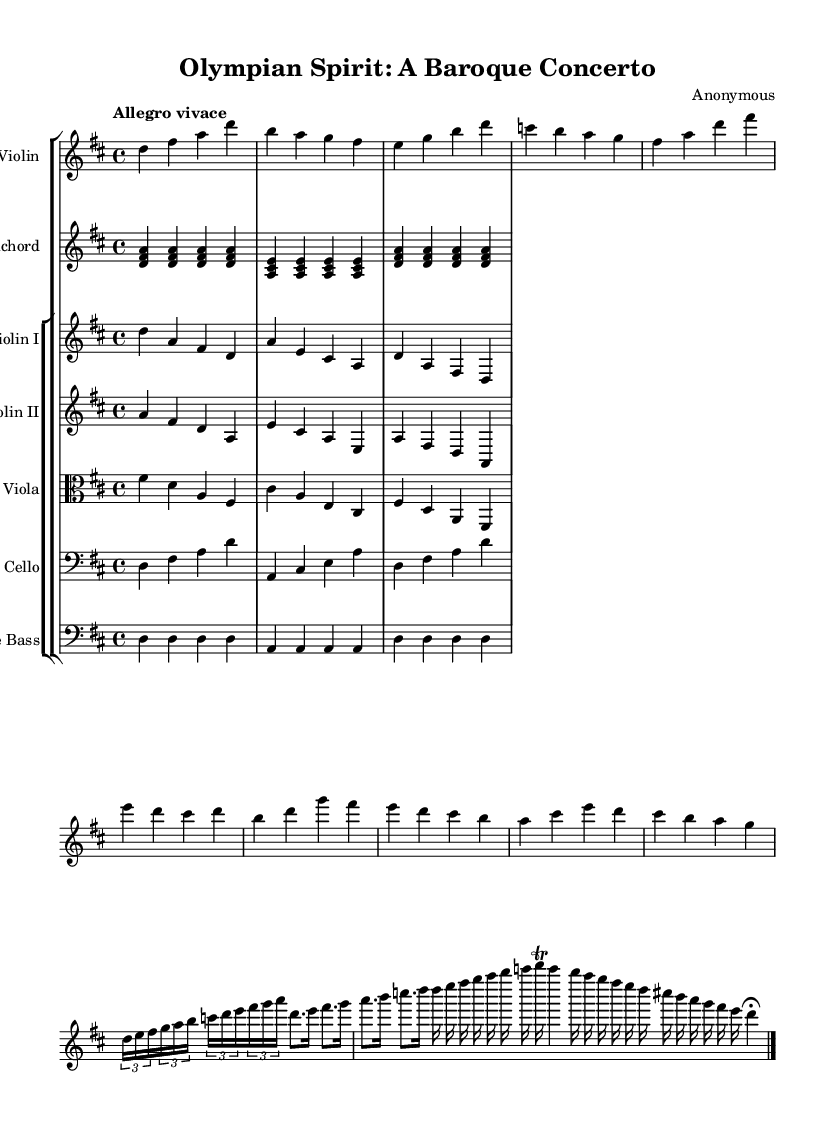What is the key signature of this music? The key signature shows two sharps, which indicates D major.
Answer: D major What is the time signature of this music? The time signature is 4/4, signifying four beats per measure.
Answer: 4/4 What is the tempo marking for this concerto? The tempo marking "Allegro vivace" indicates a fast and lively speed.
Answer: Allegro vivace What instrument plays the main solo part? The main solo part is played by the violin, specifically labeled as "Solo Violin."
Answer: Solo Violin What is the structure of this concerto? The concerto follows a typical Baroque structure with a solo exposition, thematic development, and a cadenza.
Answer: Concerto structure How many different string instruments are included in the score? The score includes five types of string instruments: solo violin, violins I and II, viola, cello, and double bass.
Answer: Five What rhythmic motif is featured prominently in the solo part? The prominent rhythmic motif consists of triplets followed by a sequence of eighth and sixteenth notes.
Answer: Triplet motif 